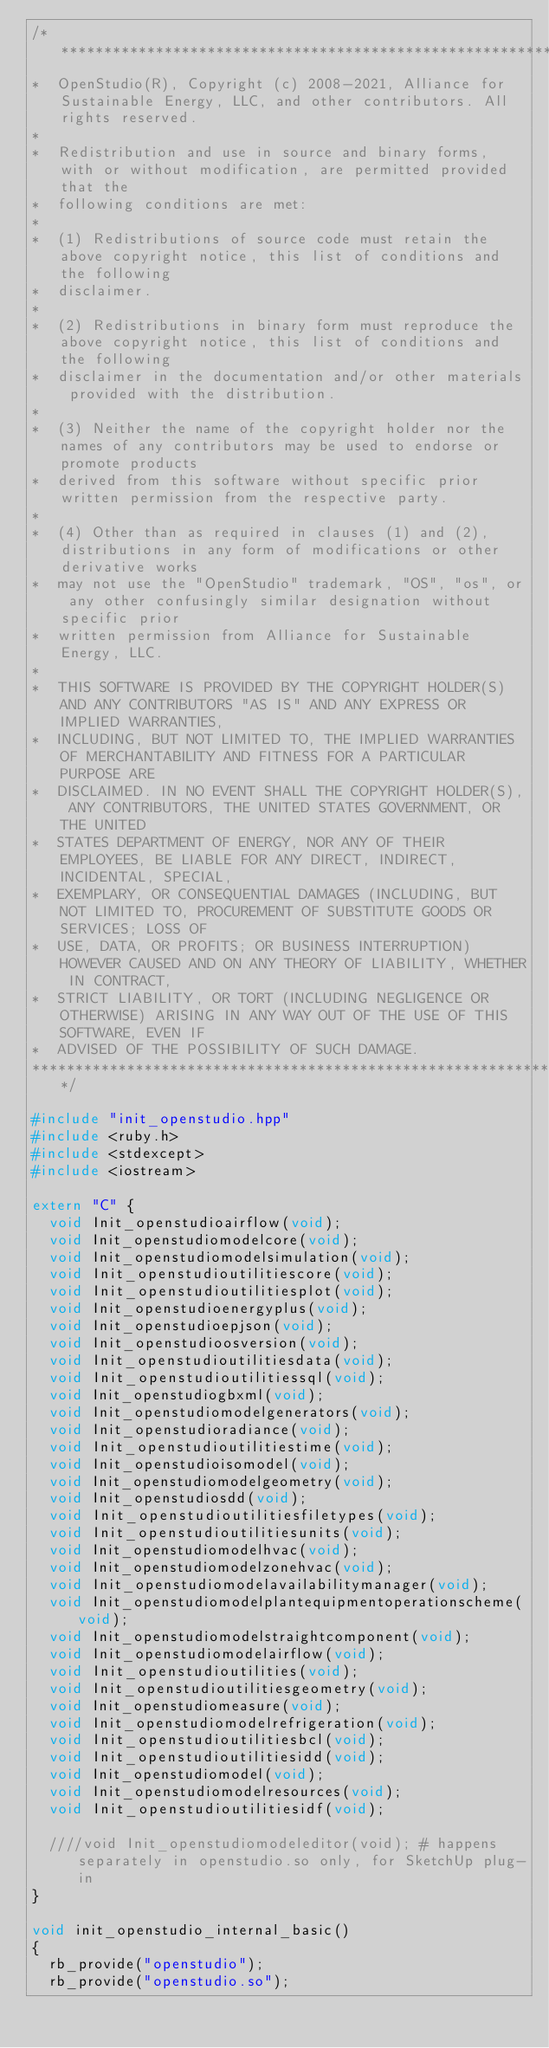<code> <loc_0><loc_0><loc_500><loc_500><_C++_>/***********************************************************************************************************************
*  OpenStudio(R), Copyright (c) 2008-2021, Alliance for Sustainable Energy, LLC, and other contributors. All rights reserved.
*
*  Redistribution and use in source and binary forms, with or without modification, are permitted provided that the
*  following conditions are met:
*
*  (1) Redistributions of source code must retain the above copyright notice, this list of conditions and the following
*  disclaimer.
*
*  (2) Redistributions in binary form must reproduce the above copyright notice, this list of conditions and the following
*  disclaimer in the documentation and/or other materials provided with the distribution.
*
*  (3) Neither the name of the copyright holder nor the names of any contributors may be used to endorse or promote products
*  derived from this software without specific prior written permission from the respective party.
*
*  (4) Other than as required in clauses (1) and (2), distributions in any form of modifications or other derivative works
*  may not use the "OpenStudio" trademark, "OS", "os", or any other confusingly similar designation without specific prior
*  written permission from Alliance for Sustainable Energy, LLC.
*
*  THIS SOFTWARE IS PROVIDED BY THE COPYRIGHT HOLDER(S) AND ANY CONTRIBUTORS "AS IS" AND ANY EXPRESS OR IMPLIED WARRANTIES,
*  INCLUDING, BUT NOT LIMITED TO, THE IMPLIED WARRANTIES OF MERCHANTABILITY AND FITNESS FOR A PARTICULAR PURPOSE ARE
*  DISCLAIMED. IN NO EVENT SHALL THE COPYRIGHT HOLDER(S), ANY CONTRIBUTORS, THE UNITED STATES GOVERNMENT, OR THE UNITED
*  STATES DEPARTMENT OF ENERGY, NOR ANY OF THEIR EMPLOYEES, BE LIABLE FOR ANY DIRECT, INDIRECT, INCIDENTAL, SPECIAL,
*  EXEMPLARY, OR CONSEQUENTIAL DAMAGES (INCLUDING, BUT NOT LIMITED TO, PROCUREMENT OF SUBSTITUTE GOODS OR SERVICES; LOSS OF
*  USE, DATA, OR PROFITS; OR BUSINESS INTERRUPTION) HOWEVER CAUSED AND ON ANY THEORY OF LIABILITY, WHETHER IN CONTRACT,
*  STRICT LIABILITY, OR TORT (INCLUDING NEGLIGENCE OR OTHERWISE) ARISING IN ANY WAY OUT OF THE USE OF THIS SOFTWARE, EVEN IF
*  ADVISED OF THE POSSIBILITY OF SUCH DAMAGE.
***********************************************************************************************************************/

#include "init_openstudio.hpp"
#include <ruby.h>
#include <stdexcept>
#include <iostream>

extern "C" {
  void Init_openstudioairflow(void);
  void Init_openstudiomodelcore(void);
  void Init_openstudiomodelsimulation(void);
  void Init_openstudioutilitiescore(void);
  void Init_openstudioutilitiesplot(void);
  void Init_openstudioenergyplus(void);
  void Init_openstudioepjson(void);
  void Init_openstudioosversion(void);
  void Init_openstudioutilitiesdata(void);
  void Init_openstudioutilitiessql(void);
  void Init_openstudiogbxml(void); 
  void Init_openstudiomodelgenerators(void);
  void Init_openstudioradiance(void);
  void Init_openstudioutilitiestime(void);
  void Init_openstudioisomodel(void);
  void Init_openstudiomodelgeometry(void);
  void Init_openstudiosdd(void);
  void Init_openstudioutilitiesfiletypes(void);
  void Init_openstudioutilitiesunits(void);
  void Init_openstudiomodelhvac(void);
  void Init_openstudiomodelzonehvac(void);
  void Init_openstudiomodelavailabilitymanager(void);
  void Init_openstudiomodelplantequipmentoperationscheme(void);
  void Init_openstudiomodelstraightcomponent(void);
  void Init_openstudiomodelairflow(void);
  void Init_openstudioutilities(void);
  void Init_openstudioutilitiesgeometry(void);
  void Init_openstudiomeasure(void);
  void Init_openstudiomodelrefrigeration(void);
  void Init_openstudioutilitiesbcl(void);
  void Init_openstudioutilitiesidd(void);
  void Init_openstudiomodel(void);
  void Init_openstudiomodelresources(void);
  void Init_openstudioutilitiesidf(void);

  ////void Init_openstudiomodeleditor(void); # happens separately in openstudio.so only, for SketchUp plug-in
}

void init_openstudio_internal_basic()
{
  rb_provide("openstudio");
  rb_provide("openstudio.so");
</code> 